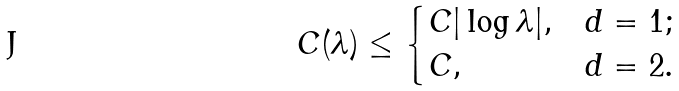<formula> <loc_0><loc_0><loc_500><loc_500>C ( \lambda ) \leq \begin{cases} C | \log \lambda | , & d = 1 ; \\ C , & d = 2 . \end{cases}</formula> 